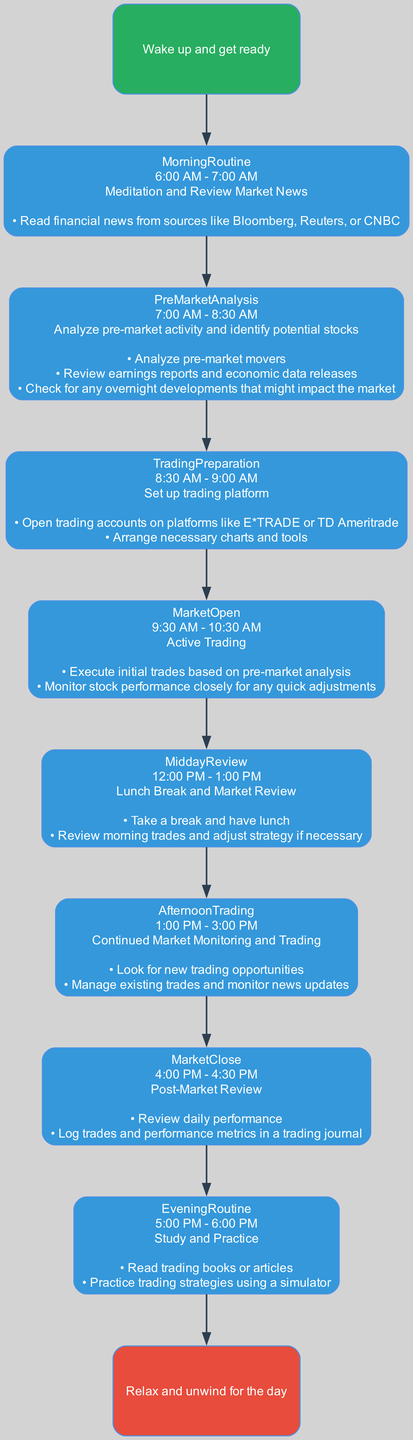What is the first task of the daily schedule? The diagram indicates that the first task is to "Wake up and get ready," which is labeled as the starting node in the flow chart.
Answer: Wake up and get ready What time frame is allocated for the Morning Routine? The diagram shows that the Morning Routine occurs from 6:00 AM to 7:00 AM, clearly stated under its respective task node.
Answer: 6:00 AM - 7:00 AM How many tasks are there in the daily schedule? By counting the nodes in the diagram excluding the Start and End nodes, there are seven tasks listed, demonstrating all the steps in the daily schedule.
Answer: 7 What is the task during the Market Close? The diagram specifies that the task during the Market Close is to "Post-Market Review," which summarizes the activities at that particular stage.
Answer: Post-Market Review During which time is the Afternoon Trading scheduled? According to the flow chart, the Afternoon Trading is scheduled from 1:00 PM to 3:00 PM, indicated in the corresponding task node.
Answer: 1:00 PM - 3:00 PM Which task follows Market Open? The flow chart directs from Market Open to Midday Review, indicating that Midday Review is the immediate next task following Market Open.
Answer: Midday Review What is the task for the Evening Routine? The Evening Routine task outlined in the chart refers to "Study and Practice," showing the focus on learning after the trading activities are completed.
Answer: Study and Practice How is the trading day concluded according to the diagram? At the end of the diagram, it shows that the trading day is concluded with the task "Relax and unwind for the day," indicating a winding down after all market activities.
Answer: Relax and unwind for the day What key considerations should be made during the Pre-Market Analysis? The diagram highlights the need to analyze pre-market movers, review earnings reports, and check overnight developments, which are critical for informed decision-making before trading starts.
Answer: Analyze pre-market movers, review earnings reports, check overnight developments 